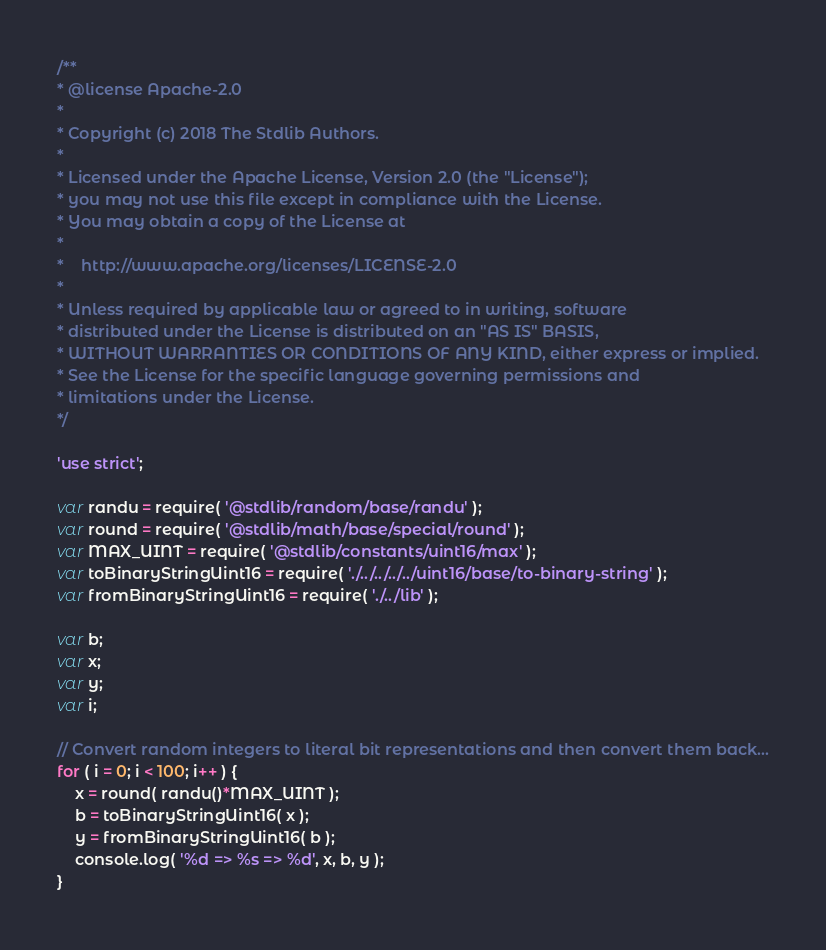<code> <loc_0><loc_0><loc_500><loc_500><_JavaScript_>/**
* @license Apache-2.0
*
* Copyright (c) 2018 The Stdlib Authors.
*
* Licensed under the Apache License, Version 2.0 (the "License");
* you may not use this file except in compliance with the License.
* You may obtain a copy of the License at
*
*    http://www.apache.org/licenses/LICENSE-2.0
*
* Unless required by applicable law or agreed to in writing, software
* distributed under the License is distributed on an "AS IS" BASIS,
* WITHOUT WARRANTIES OR CONDITIONS OF ANY KIND, either express or implied.
* See the License for the specific language governing permissions and
* limitations under the License.
*/

'use strict';

var randu = require( '@stdlib/random/base/randu' );
var round = require( '@stdlib/math/base/special/round' );
var MAX_UINT = require( '@stdlib/constants/uint16/max' );
var toBinaryStringUint16 = require( './../../../../uint16/base/to-binary-string' );
var fromBinaryStringUint16 = require( './../lib' );

var b;
var x;
var y;
var i;

// Convert random integers to literal bit representations and then convert them back...
for ( i = 0; i < 100; i++ ) {
	x = round( randu()*MAX_UINT );
	b = toBinaryStringUint16( x );
	y = fromBinaryStringUint16( b );
	console.log( '%d => %s => %d', x, b, y );
}
</code> 